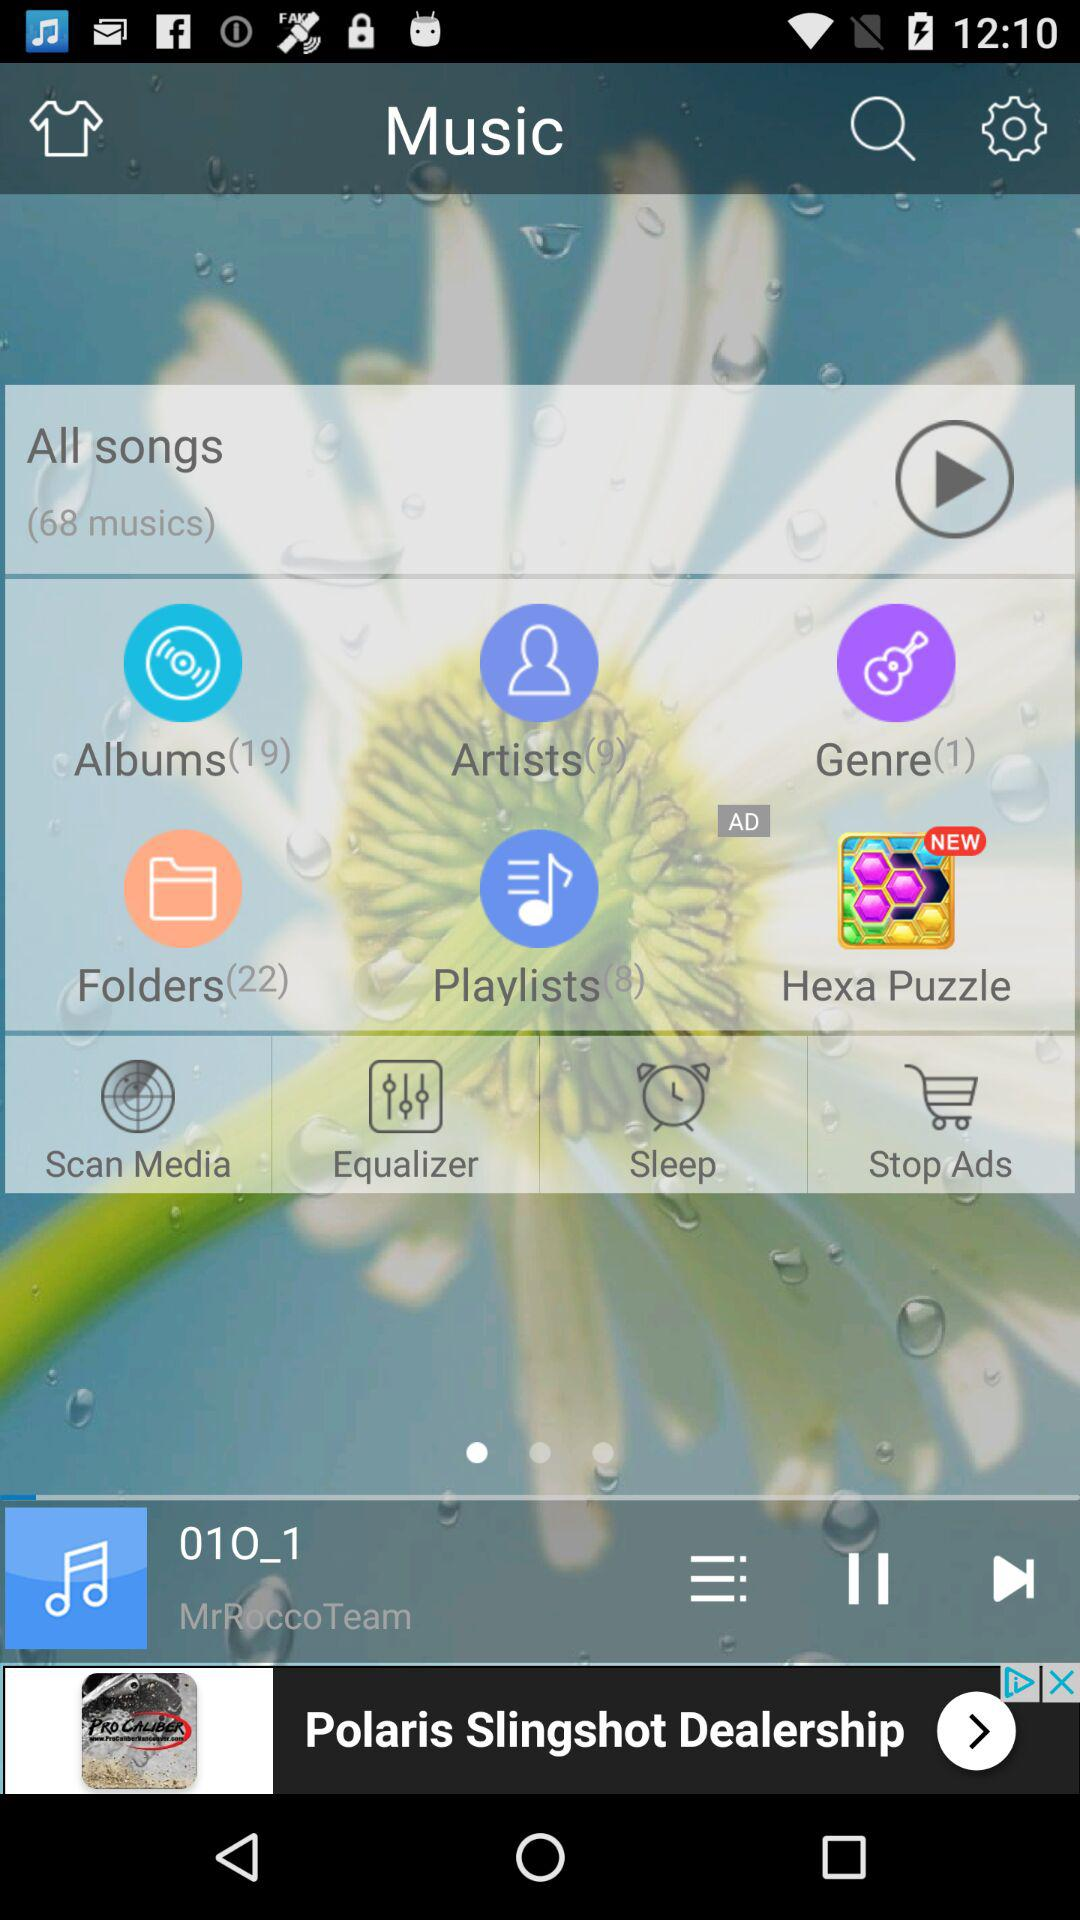What is the total number of files in the "Albums" folder? The total number of files in the "Albums" folder is 19. 